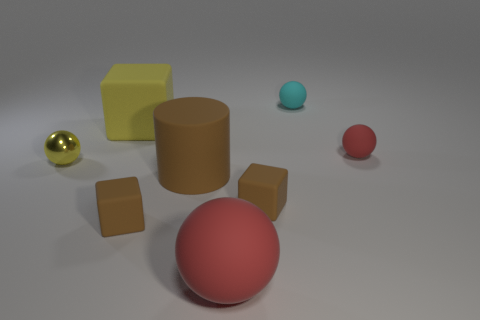Subtract all small cyan matte spheres. How many spheres are left? 3 Add 1 small yellow cylinders. How many objects exist? 9 Subtract all yellow cylinders. How many red spheres are left? 2 Subtract all cylinders. How many objects are left? 7 Subtract 2 balls. How many balls are left? 2 Subtract all red balls. How many balls are left? 2 Subtract 2 red balls. How many objects are left? 6 Subtract all purple spheres. Subtract all blue blocks. How many spheres are left? 4 Subtract all tiny blue shiny cylinders. Subtract all yellow metal spheres. How many objects are left? 7 Add 4 brown cylinders. How many brown cylinders are left? 5 